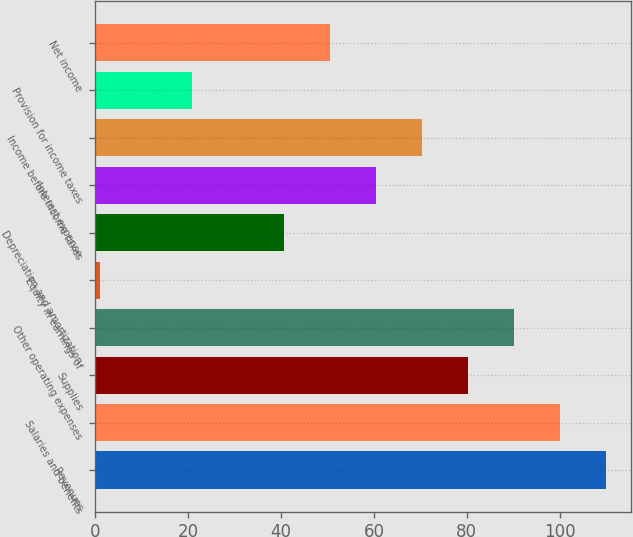Convert chart to OTSL. <chart><loc_0><loc_0><loc_500><loc_500><bar_chart><fcel>Revenues<fcel>Salaries and benefits<fcel>Supplies<fcel>Other operating expenses<fcel>Equity in earnings of<fcel>Depreciation and amortization<fcel>Interest expense<fcel>Income before income taxes<fcel>Provision for income taxes<fcel>Net income<nl><fcel>109.9<fcel>100<fcel>80.2<fcel>90.1<fcel>1<fcel>40.6<fcel>60.4<fcel>70.3<fcel>20.8<fcel>50.5<nl></chart> 